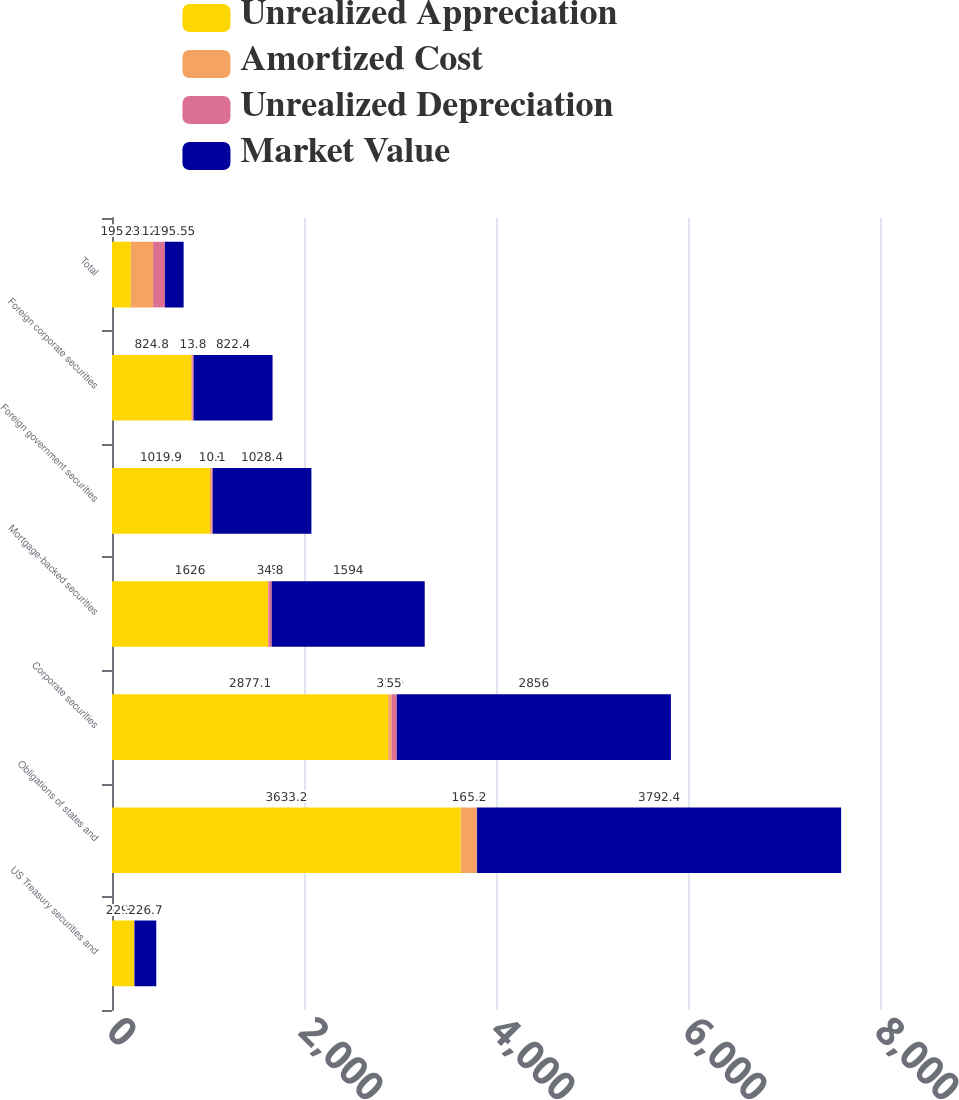<chart> <loc_0><loc_0><loc_500><loc_500><stacked_bar_chart><ecel><fcel>US Treasury securities and<fcel>Obligations of states and<fcel>Corporate securities<fcel>Mortgage-backed securities<fcel>Foreign government securities<fcel>Foreign corporate securities<fcel>Total<nl><fcel>Unrealized Appreciation<fcel>229.2<fcel>3633.2<fcel>2877.1<fcel>1626<fcel>1019.9<fcel>824.8<fcel>195.55<nl><fcel>Amortized Cost<fcel>1.3<fcel>164.4<fcel>33.9<fcel>2.8<fcel>18.6<fcel>11.4<fcel>232.4<nl><fcel>Unrealized Depreciation<fcel>3.8<fcel>5.2<fcel>55<fcel>34.8<fcel>10.1<fcel>13.8<fcel>122.7<nl><fcel>Market Value<fcel>226.7<fcel>3792.4<fcel>2856<fcel>1594<fcel>1028.4<fcel>822.4<fcel>195.55<nl></chart> 